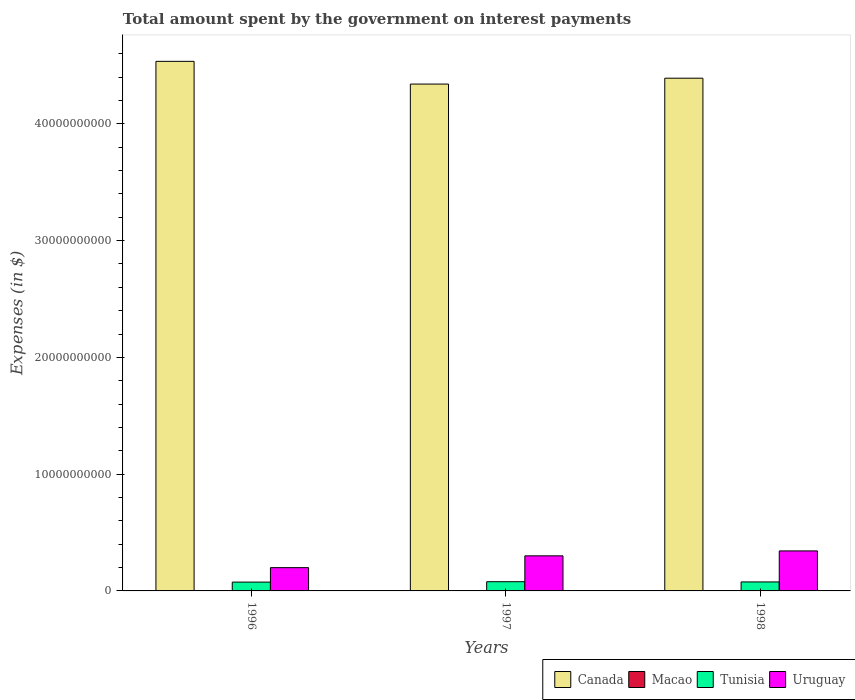Are the number of bars on each tick of the X-axis equal?
Provide a short and direct response. Yes. How many bars are there on the 1st tick from the right?
Keep it short and to the point. 4. What is the label of the 2nd group of bars from the left?
Offer a terse response. 1997. What is the amount spent on interest payments by the government in Canada in 1996?
Give a very brief answer. 4.54e+1. Across all years, what is the maximum amount spent on interest payments by the government in Canada?
Provide a short and direct response. 4.54e+1. Across all years, what is the minimum amount spent on interest payments by the government in Uruguay?
Your answer should be very brief. 1.99e+09. In which year was the amount spent on interest payments by the government in Tunisia maximum?
Give a very brief answer. 1997. What is the total amount spent on interest payments by the government in Tunisia in the graph?
Make the answer very short. 2.31e+09. What is the difference between the amount spent on interest payments by the government in Tunisia in 1997 and that in 1998?
Keep it short and to the point. 1.87e+07. What is the difference between the amount spent on interest payments by the government in Uruguay in 1998 and the amount spent on interest payments by the government in Macao in 1996?
Offer a terse response. 3.42e+09. What is the average amount spent on interest payments by the government in Uruguay per year?
Offer a terse response. 2.81e+09. In the year 1996, what is the difference between the amount spent on interest payments by the government in Uruguay and amount spent on interest payments by the government in Macao?
Offer a terse response. 1.99e+09. In how many years, is the amount spent on interest payments by the government in Macao greater than 42000000000 $?
Provide a succinct answer. 0. What is the ratio of the amount spent on interest payments by the government in Uruguay in 1997 to that in 1998?
Your answer should be very brief. 0.88. Is the amount spent on interest payments by the government in Tunisia in 1996 less than that in 1998?
Your response must be concise. Yes. What is the difference between the highest and the second highest amount spent on interest payments by the government in Uruguay?
Your answer should be compact. 4.21e+08. What is the difference between the highest and the lowest amount spent on interest payments by the government in Macao?
Provide a succinct answer. 3.77e+06. In how many years, is the amount spent on interest payments by the government in Canada greater than the average amount spent on interest payments by the government in Canada taken over all years?
Ensure brevity in your answer.  1. Is the sum of the amount spent on interest payments by the government in Canada in 1996 and 1997 greater than the maximum amount spent on interest payments by the government in Tunisia across all years?
Make the answer very short. Yes. What does the 3rd bar from the left in 1997 represents?
Give a very brief answer. Tunisia. What does the 1st bar from the right in 1996 represents?
Provide a succinct answer. Uruguay. Is it the case that in every year, the sum of the amount spent on interest payments by the government in Macao and amount spent on interest payments by the government in Uruguay is greater than the amount spent on interest payments by the government in Canada?
Provide a short and direct response. No. How many years are there in the graph?
Provide a succinct answer. 3. What is the difference between two consecutive major ticks on the Y-axis?
Make the answer very short. 1.00e+1. Does the graph contain grids?
Your answer should be compact. No. Where does the legend appear in the graph?
Provide a succinct answer. Bottom right. How are the legend labels stacked?
Provide a short and direct response. Horizontal. What is the title of the graph?
Keep it short and to the point. Total amount spent by the government on interest payments. Does "Ireland" appear as one of the legend labels in the graph?
Your response must be concise. No. What is the label or title of the Y-axis?
Your answer should be compact. Expenses (in $). What is the Expenses (in $) of Canada in 1996?
Your answer should be very brief. 4.54e+1. What is the Expenses (in $) of Macao in 1996?
Ensure brevity in your answer.  3.96e+06. What is the Expenses (in $) in Tunisia in 1996?
Provide a short and direct response. 7.55e+08. What is the Expenses (in $) in Uruguay in 1996?
Provide a succinct answer. 1.99e+09. What is the Expenses (in $) in Canada in 1997?
Ensure brevity in your answer.  4.34e+1. What is the Expenses (in $) of Tunisia in 1997?
Offer a terse response. 7.89e+08. What is the Expenses (in $) in Uruguay in 1997?
Your response must be concise. 3.00e+09. What is the Expenses (in $) of Canada in 1998?
Your answer should be compact. 4.39e+1. What is the Expenses (in $) of Macao in 1998?
Your answer should be compact. 1.13e+06. What is the Expenses (in $) in Tunisia in 1998?
Keep it short and to the point. 7.70e+08. What is the Expenses (in $) of Uruguay in 1998?
Your answer should be very brief. 3.43e+09. Across all years, what is the maximum Expenses (in $) in Canada?
Give a very brief answer. 4.54e+1. Across all years, what is the maximum Expenses (in $) of Macao?
Make the answer very short. 3.96e+06. Across all years, what is the maximum Expenses (in $) of Tunisia?
Your answer should be very brief. 7.89e+08. Across all years, what is the maximum Expenses (in $) in Uruguay?
Offer a terse response. 3.43e+09. Across all years, what is the minimum Expenses (in $) of Canada?
Provide a succinct answer. 4.34e+1. Across all years, what is the minimum Expenses (in $) of Tunisia?
Your response must be concise. 7.55e+08. Across all years, what is the minimum Expenses (in $) in Uruguay?
Ensure brevity in your answer.  1.99e+09. What is the total Expenses (in $) in Canada in the graph?
Give a very brief answer. 1.33e+11. What is the total Expenses (in $) in Macao in the graph?
Keep it short and to the point. 5.28e+06. What is the total Expenses (in $) in Tunisia in the graph?
Offer a very short reply. 2.31e+09. What is the total Expenses (in $) of Uruguay in the graph?
Offer a terse response. 8.42e+09. What is the difference between the Expenses (in $) of Canada in 1996 and that in 1997?
Give a very brief answer. 1.94e+09. What is the difference between the Expenses (in $) in Macao in 1996 and that in 1997?
Your answer should be very brief. 3.77e+06. What is the difference between the Expenses (in $) in Tunisia in 1996 and that in 1997?
Offer a very short reply. -3.40e+07. What is the difference between the Expenses (in $) in Uruguay in 1996 and that in 1997?
Give a very brief answer. -1.01e+09. What is the difference between the Expenses (in $) in Canada in 1996 and that in 1998?
Offer a terse response. 1.44e+09. What is the difference between the Expenses (in $) of Macao in 1996 and that in 1998?
Offer a terse response. 2.83e+06. What is the difference between the Expenses (in $) in Tunisia in 1996 and that in 1998?
Make the answer very short. -1.53e+07. What is the difference between the Expenses (in $) in Uruguay in 1996 and that in 1998?
Your answer should be compact. -1.43e+09. What is the difference between the Expenses (in $) in Canada in 1997 and that in 1998?
Keep it short and to the point. -5.03e+08. What is the difference between the Expenses (in $) of Macao in 1997 and that in 1998?
Ensure brevity in your answer.  -9.40e+05. What is the difference between the Expenses (in $) of Tunisia in 1997 and that in 1998?
Offer a very short reply. 1.87e+07. What is the difference between the Expenses (in $) of Uruguay in 1997 and that in 1998?
Offer a very short reply. -4.21e+08. What is the difference between the Expenses (in $) in Canada in 1996 and the Expenses (in $) in Macao in 1997?
Offer a very short reply. 4.54e+1. What is the difference between the Expenses (in $) in Canada in 1996 and the Expenses (in $) in Tunisia in 1997?
Keep it short and to the point. 4.46e+1. What is the difference between the Expenses (in $) in Canada in 1996 and the Expenses (in $) in Uruguay in 1997?
Offer a terse response. 4.23e+1. What is the difference between the Expenses (in $) of Macao in 1996 and the Expenses (in $) of Tunisia in 1997?
Provide a succinct answer. -7.85e+08. What is the difference between the Expenses (in $) of Macao in 1996 and the Expenses (in $) of Uruguay in 1997?
Your answer should be compact. -3.00e+09. What is the difference between the Expenses (in $) of Tunisia in 1996 and the Expenses (in $) of Uruguay in 1997?
Provide a succinct answer. -2.25e+09. What is the difference between the Expenses (in $) in Canada in 1996 and the Expenses (in $) in Macao in 1998?
Your answer should be compact. 4.54e+1. What is the difference between the Expenses (in $) of Canada in 1996 and the Expenses (in $) of Tunisia in 1998?
Keep it short and to the point. 4.46e+1. What is the difference between the Expenses (in $) of Canada in 1996 and the Expenses (in $) of Uruguay in 1998?
Your response must be concise. 4.19e+1. What is the difference between the Expenses (in $) in Macao in 1996 and the Expenses (in $) in Tunisia in 1998?
Make the answer very short. -7.66e+08. What is the difference between the Expenses (in $) of Macao in 1996 and the Expenses (in $) of Uruguay in 1998?
Your answer should be compact. -3.42e+09. What is the difference between the Expenses (in $) in Tunisia in 1996 and the Expenses (in $) in Uruguay in 1998?
Offer a very short reply. -2.67e+09. What is the difference between the Expenses (in $) of Canada in 1997 and the Expenses (in $) of Macao in 1998?
Your response must be concise. 4.34e+1. What is the difference between the Expenses (in $) in Canada in 1997 and the Expenses (in $) in Tunisia in 1998?
Your response must be concise. 4.26e+1. What is the difference between the Expenses (in $) of Canada in 1997 and the Expenses (in $) of Uruguay in 1998?
Keep it short and to the point. 4.00e+1. What is the difference between the Expenses (in $) in Macao in 1997 and the Expenses (in $) in Tunisia in 1998?
Offer a very short reply. -7.70e+08. What is the difference between the Expenses (in $) in Macao in 1997 and the Expenses (in $) in Uruguay in 1998?
Provide a short and direct response. -3.43e+09. What is the difference between the Expenses (in $) of Tunisia in 1997 and the Expenses (in $) of Uruguay in 1998?
Offer a very short reply. -2.64e+09. What is the average Expenses (in $) of Canada per year?
Make the answer very short. 4.42e+1. What is the average Expenses (in $) of Macao per year?
Your answer should be compact. 1.76e+06. What is the average Expenses (in $) in Tunisia per year?
Give a very brief answer. 7.71e+08. What is the average Expenses (in $) of Uruguay per year?
Make the answer very short. 2.81e+09. In the year 1996, what is the difference between the Expenses (in $) of Canada and Expenses (in $) of Macao?
Provide a succinct answer. 4.53e+1. In the year 1996, what is the difference between the Expenses (in $) in Canada and Expenses (in $) in Tunisia?
Your response must be concise. 4.46e+1. In the year 1996, what is the difference between the Expenses (in $) in Canada and Expenses (in $) in Uruguay?
Your response must be concise. 4.34e+1. In the year 1996, what is the difference between the Expenses (in $) in Macao and Expenses (in $) in Tunisia?
Your answer should be compact. -7.51e+08. In the year 1996, what is the difference between the Expenses (in $) of Macao and Expenses (in $) of Uruguay?
Offer a very short reply. -1.99e+09. In the year 1996, what is the difference between the Expenses (in $) in Tunisia and Expenses (in $) in Uruguay?
Your answer should be very brief. -1.24e+09. In the year 1997, what is the difference between the Expenses (in $) in Canada and Expenses (in $) in Macao?
Offer a terse response. 4.34e+1. In the year 1997, what is the difference between the Expenses (in $) in Canada and Expenses (in $) in Tunisia?
Offer a very short reply. 4.26e+1. In the year 1997, what is the difference between the Expenses (in $) in Canada and Expenses (in $) in Uruguay?
Offer a very short reply. 4.04e+1. In the year 1997, what is the difference between the Expenses (in $) of Macao and Expenses (in $) of Tunisia?
Keep it short and to the point. -7.89e+08. In the year 1997, what is the difference between the Expenses (in $) of Macao and Expenses (in $) of Uruguay?
Provide a succinct answer. -3.00e+09. In the year 1997, what is the difference between the Expenses (in $) in Tunisia and Expenses (in $) in Uruguay?
Make the answer very short. -2.22e+09. In the year 1998, what is the difference between the Expenses (in $) in Canada and Expenses (in $) in Macao?
Keep it short and to the point. 4.39e+1. In the year 1998, what is the difference between the Expenses (in $) of Canada and Expenses (in $) of Tunisia?
Offer a terse response. 4.31e+1. In the year 1998, what is the difference between the Expenses (in $) in Canada and Expenses (in $) in Uruguay?
Offer a very short reply. 4.05e+1. In the year 1998, what is the difference between the Expenses (in $) in Macao and Expenses (in $) in Tunisia?
Make the answer very short. -7.69e+08. In the year 1998, what is the difference between the Expenses (in $) of Macao and Expenses (in $) of Uruguay?
Offer a terse response. -3.42e+09. In the year 1998, what is the difference between the Expenses (in $) in Tunisia and Expenses (in $) in Uruguay?
Ensure brevity in your answer.  -2.66e+09. What is the ratio of the Expenses (in $) of Canada in 1996 to that in 1997?
Make the answer very short. 1.04. What is the ratio of the Expenses (in $) of Macao in 1996 to that in 1997?
Your answer should be compact. 20.84. What is the ratio of the Expenses (in $) of Tunisia in 1996 to that in 1997?
Offer a terse response. 0.96. What is the ratio of the Expenses (in $) in Uruguay in 1996 to that in 1997?
Your answer should be very brief. 0.66. What is the ratio of the Expenses (in $) in Canada in 1996 to that in 1998?
Provide a succinct answer. 1.03. What is the ratio of the Expenses (in $) in Macao in 1996 to that in 1998?
Offer a terse response. 3.5. What is the ratio of the Expenses (in $) of Tunisia in 1996 to that in 1998?
Ensure brevity in your answer.  0.98. What is the ratio of the Expenses (in $) in Uruguay in 1996 to that in 1998?
Provide a succinct answer. 0.58. What is the ratio of the Expenses (in $) of Macao in 1997 to that in 1998?
Provide a succinct answer. 0.17. What is the ratio of the Expenses (in $) in Tunisia in 1997 to that in 1998?
Provide a short and direct response. 1.02. What is the ratio of the Expenses (in $) of Uruguay in 1997 to that in 1998?
Provide a succinct answer. 0.88. What is the difference between the highest and the second highest Expenses (in $) of Canada?
Ensure brevity in your answer.  1.44e+09. What is the difference between the highest and the second highest Expenses (in $) of Macao?
Offer a very short reply. 2.83e+06. What is the difference between the highest and the second highest Expenses (in $) in Tunisia?
Offer a very short reply. 1.87e+07. What is the difference between the highest and the second highest Expenses (in $) of Uruguay?
Give a very brief answer. 4.21e+08. What is the difference between the highest and the lowest Expenses (in $) of Canada?
Provide a short and direct response. 1.94e+09. What is the difference between the highest and the lowest Expenses (in $) of Macao?
Make the answer very short. 3.77e+06. What is the difference between the highest and the lowest Expenses (in $) in Tunisia?
Offer a very short reply. 3.40e+07. What is the difference between the highest and the lowest Expenses (in $) in Uruguay?
Offer a terse response. 1.43e+09. 